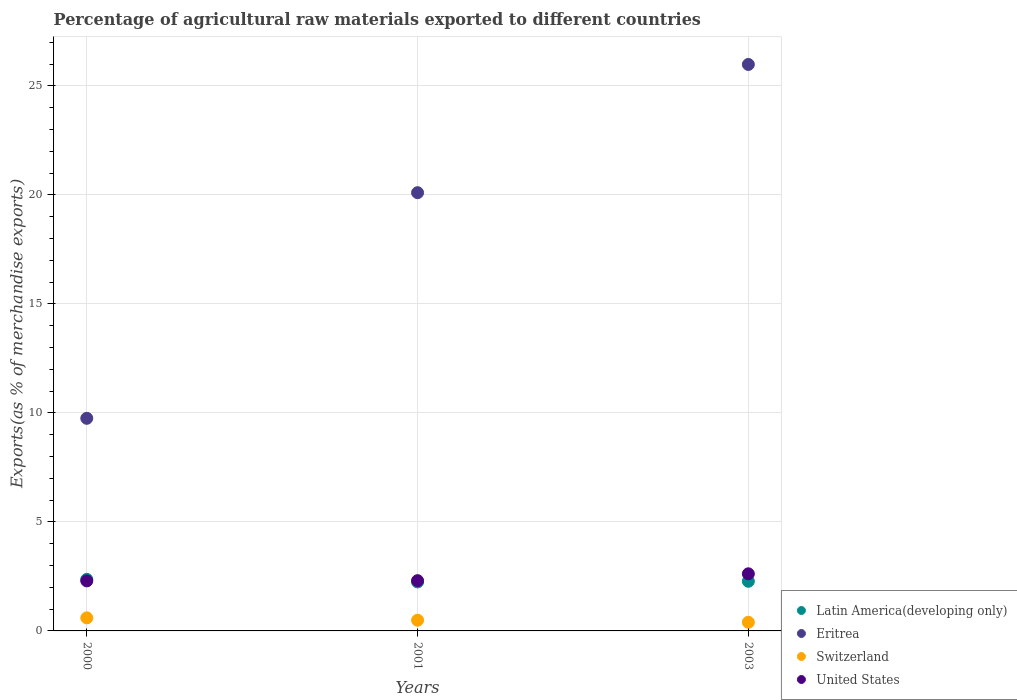What is the percentage of exports to different countries in Switzerland in 2001?
Your response must be concise. 0.49. Across all years, what is the maximum percentage of exports to different countries in Switzerland?
Offer a very short reply. 0.6. Across all years, what is the minimum percentage of exports to different countries in Eritrea?
Provide a succinct answer. 9.75. In which year was the percentage of exports to different countries in United States maximum?
Your response must be concise. 2003. What is the total percentage of exports to different countries in Latin America(developing only) in the graph?
Your response must be concise. 6.89. What is the difference between the percentage of exports to different countries in Switzerland in 2000 and that in 2003?
Provide a succinct answer. 0.2. What is the difference between the percentage of exports to different countries in Eritrea in 2003 and the percentage of exports to different countries in Switzerland in 2000?
Your response must be concise. 25.39. What is the average percentage of exports to different countries in Switzerland per year?
Offer a terse response. 0.5. In the year 2000, what is the difference between the percentage of exports to different countries in Switzerland and percentage of exports to different countries in Latin America(developing only)?
Offer a terse response. -1.77. What is the ratio of the percentage of exports to different countries in Latin America(developing only) in 2000 to that in 2001?
Keep it short and to the point. 1.05. Is the percentage of exports to different countries in Switzerland in 2000 less than that in 2003?
Your answer should be very brief. No. Is the difference between the percentage of exports to different countries in Switzerland in 2000 and 2001 greater than the difference between the percentage of exports to different countries in Latin America(developing only) in 2000 and 2001?
Make the answer very short. No. What is the difference between the highest and the second highest percentage of exports to different countries in Latin America(developing only)?
Your response must be concise. 0.09. What is the difference between the highest and the lowest percentage of exports to different countries in Switzerland?
Keep it short and to the point. 0.2. Is the sum of the percentage of exports to different countries in Eritrea in 2000 and 2001 greater than the maximum percentage of exports to different countries in Switzerland across all years?
Offer a terse response. Yes. Is it the case that in every year, the sum of the percentage of exports to different countries in United States and percentage of exports to different countries in Eritrea  is greater than the sum of percentage of exports to different countries in Switzerland and percentage of exports to different countries in Latin America(developing only)?
Your answer should be very brief. Yes. Is it the case that in every year, the sum of the percentage of exports to different countries in Eritrea and percentage of exports to different countries in United States  is greater than the percentage of exports to different countries in Switzerland?
Give a very brief answer. Yes. Is the percentage of exports to different countries in United States strictly less than the percentage of exports to different countries in Eritrea over the years?
Your answer should be very brief. Yes. How many years are there in the graph?
Your answer should be very brief. 3. What is the difference between two consecutive major ticks on the Y-axis?
Offer a very short reply. 5. Are the values on the major ticks of Y-axis written in scientific E-notation?
Offer a very short reply. No. How many legend labels are there?
Ensure brevity in your answer.  4. What is the title of the graph?
Offer a terse response. Percentage of agricultural raw materials exported to different countries. What is the label or title of the X-axis?
Keep it short and to the point. Years. What is the label or title of the Y-axis?
Your answer should be very brief. Exports(as % of merchandise exports). What is the Exports(as % of merchandise exports) of Latin America(developing only) in 2000?
Offer a very short reply. 2.36. What is the Exports(as % of merchandise exports) in Eritrea in 2000?
Provide a succinct answer. 9.75. What is the Exports(as % of merchandise exports) of Switzerland in 2000?
Ensure brevity in your answer.  0.6. What is the Exports(as % of merchandise exports) in United States in 2000?
Provide a succinct answer. 2.3. What is the Exports(as % of merchandise exports) in Latin America(developing only) in 2001?
Give a very brief answer. 2.25. What is the Exports(as % of merchandise exports) of Eritrea in 2001?
Your response must be concise. 20.1. What is the Exports(as % of merchandise exports) of Switzerland in 2001?
Ensure brevity in your answer.  0.49. What is the Exports(as % of merchandise exports) of United States in 2001?
Ensure brevity in your answer.  2.31. What is the Exports(as % of merchandise exports) in Latin America(developing only) in 2003?
Ensure brevity in your answer.  2.28. What is the Exports(as % of merchandise exports) of Eritrea in 2003?
Give a very brief answer. 25.99. What is the Exports(as % of merchandise exports) of Switzerland in 2003?
Offer a terse response. 0.4. What is the Exports(as % of merchandise exports) in United States in 2003?
Your response must be concise. 2.62. Across all years, what is the maximum Exports(as % of merchandise exports) of Latin America(developing only)?
Your answer should be very brief. 2.36. Across all years, what is the maximum Exports(as % of merchandise exports) of Eritrea?
Your answer should be compact. 25.99. Across all years, what is the maximum Exports(as % of merchandise exports) in Switzerland?
Provide a short and direct response. 0.6. Across all years, what is the maximum Exports(as % of merchandise exports) of United States?
Your response must be concise. 2.62. Across all years, what is the minimum Exports(as % of merchandise exports) of Latin America(developing only)?
Ensure brevity in your answer.  2.25. Across all years, what is the minimum Exports(as % of merchandise exports) in Eritrea?
Keep it short and to the point. 9.75. Across all years, what is the minimum Exports(as % of merchandise exports) in Switzerland?
Keep it short and to the point. 0.4. Across all years, what is the minimum Exports(as % of merchandise exports) of United States?
Give a very brief answer. 2.3. What is the total Exports(as % of merchandise exports) of Latin America(developing only) in the graph?
Offer a very short reply. 6.89. What is the total Exports(as % of merchandise exports) in Eritrea in the graph?
Keep it short and to the point. 55.85. What is the total Exports(as % of merchandise exports) of Switzerland in the graph?
Ensure brevity in your answer.  1.49. What is the total Exports(as % of merchandise exports) in United States in the graph?
Provide a short and direct response. 7.22. What is the difference between the Exports(as % of merchandise exports) in Latin America(developing only) in 2000 and that in 2001?
Your response must be concise. 0.12. What is the difference between the Exports(as % of merchandise exports) of Eritrea in 2000 and that in 2001?
Ensure brevity in your answer.  -10.35. What is the difference between the Exports(as % of merchandise exports) of Switzerland in 2000 and that in 2001?
Give a very brief answer. 0.11. What is the difference between the Exports(as % of merchandise exports) in United States in 2000 and that in 2001?
Ensure brevity in your answer.  -0.01. What is the difference between the Exports(as % of merchandise exports) of Latin America(developing only) in 2000 and that in 2003?
Keep it short and to the point. 0.09. What is the difference between the Exports(as % of merchandise exports) of Eritrea in 2000 and that in 2003?
Offer a very short reply. -16.23. What is the difference between the Exports(as % of merchandise exports) in Switzerland in 2000 and that in 2003?
Provide a short and direct response. 0.2. What is the difference between the Exports(as % of merchandise exports) in United States in 2000 and that in 2003?
Give a very brief answer. -0.32. What is the difference between the Exports(as % of merchandise exports) in Latin America(developing only) in 2001 and that in 2003?
Your answer should be compact. -0.03. What is the difference between the Exports(as % of merchandise exports) in Eritrea in 2001 and that in 2003?
Your answer should be compact. -5.88. What is the difference between the Exports(as % of merchandise exports) of Switzerland in 2001 and that in 2003?
Offer a terse response. 0.09. What is the difference between the Exports(as % of merchandise exports) in United States in 2001 and that in 2003?
Your answer should be very brief. -0.31. What is the difference between the Exports(as % of merchandise exports) in Latin America(developing only) in 2000 and the Exports(as % of merchandise exports) in Eritrea in 2001?
Ensure brevity in your answer.  -17.74. What is the difference between the Exports(as % of merchandise exports) of Latin America(developing only) in 2000 and the Exports(as % of merchandise exports) of Switzerland in 2001?
Give a very brief answer. 1.87. What is the difference between the Exports(as % of merchandise exports) of Latin America(developing only) in 2000 and the Exports(as % of merchandise exports) of United States in 2001?
Offer a very short reply. 0.06. What is the difference between the Exports(as % of merchandise exports) in Eritrea in 2000 and the Exports(as % of merchandise exports) in Switzerland in 2001?
Provide a succinct answer. 9.26. What is the difference between the Exports(as % of merchandise exports) in Eritrea in 2000 and the Exports(as % of merchandise exports) in United States in 2001?
Your answer should be compact. 7.45. What is the difference between the Exports(as % of merchandise exports) of Switzerland in 2000 and the Exports(as % of merchandise exports) of United States in 2001?
Your response must be concise. -1.71. What is the difference between the Exports(as % of merchandise exports) of Latin America(developing only) in 2000 and the Exports(as % of merchandise exports) of Eritrea in 2003?
Keep it short and to the point. -23.62. What is the difference between the Exports(as % of merchandise exports) of Latin America(developing only) in 2000 and the Exports(as % of merchandise exports) of Switzerland in 2003?
Your answer should be compact. 1.97. What is the difference between the Exports(as % of merchandise exports) in Latin America(developing only) in 2000 and the Exports(as % of merchandise exports) in United States in 2003?
Offer a terse response. -0.26. What is the difference between the Exports(as % of merchandise exports) of Eritrea in 2000 and the Exports(as % of merchandise exports) of Switzerland in 2003?
Give a very brief answer. 9.36. What is the difference between the Exports(as % of merchandise exports) in Eritrea in 2000 and the Exports(as % of merchandise exports) in United States in 2003?
Make the answer very short. 7.13. What is the difference between the Exports(as % of merchandise exports) of Switzerland in 2000 and the Exports(as % of merchandise exports) of United States in 2003?
Provide a short and direct response. -2.02. What is the difference between the Exports(as % of merchandise exports) in Latin America(developing only) in 2001 and the Exports(as % of merchandise exports) in Eritrea in 2003?
Provide a succinct answer. -23.74. What is the difference between the Exports(as % of merchandise exports) in Latin America(developing only) in 2001 and the Exports(as % of merchandise exports) in Switzerland in 2003?
Offer a very short reply. 1.85. What is the difference between the Exports(as % of merchandise exports) of Latin America(developing only) in 2001 and the Exports(as % of merchandise exports) of United States in 2003?
Your answer should be very brief. -0.37. What is the difference between the Exports(as % of merchandise exports) in Eritrea in 2001 and the Exports(as % of merchandise exports) in Switzerland in 2003?
Offer a very short reply. 19.71. What is the difference between the Exports(as % of merchandise exports) in Eritrea in 2001 and the Exports(as % of merchandise exports) in United States in 2003?
Offer a terse response. 17.48. What is the difference between the Exports(as % of merchandise exports) of Switzerland in 2001 and the Exports(as % of merchandise exports) of United States in 2003?
Ensure brevity in your answer.  -2.13. What is the average Exports(as % of merchandise exports) in Latin America(developing only) per year?
Offer a very short reply. 2.3. What is the average Exports(as % of merchandise exports) in Eritrea per year?
Offer a terse response. 18.62. What is the average Exports(as % of merchandise exports) of Switzerland per year?
Provide a short and direct response. 0.5. What is the average Exports(as % of merchandise exports) in United States per year?
Provide a short and direct response. 2.41. In the year 2000, what is the difference between the Exports(as % of merchandise exports) of Latin America(developing only) and Exports(as % of merchandise exports) of Eritrea?
Your response must be concise. -7.39. In the year 2000, what is the difference between the Exports(as % of merchandise exports) of Latin America(developing only) and Exports(as % of merchandise exports) of Switzerland?
Your answer should be compact. 1.77. In the year 2000, what is the difference between the Exports(as % of merchandise exports) in Latin America(developing only) and Exports(as % of merchandise exports) in United States?
Make the answer very short. 0.07. In the year 2000, what is the difference between the Exports(as % of merchandise exports) in Eritrea and Exports(as % of merchandise exports) in Switzerland?
Your response must be concise. 9.16. In the year 2000, what is the difference between the Exports(as % of merchandise exports) of Eritrea and Exports(as % of merchandise exports) of United States?
Keep it short and to the point. 7.46. In the year 2000, what is the difference between the Exports(as % of merchandise exports) of Switzerland and Exports(as % of merchandise exports) of United States?
Your answer should be compact. -1.7. In the year 2001, what is the difference between the Exports(as % of merchandise exports) in Latin America(developing only) and Exports(as % of merchandise exports) in Eritrea?
Give a very brief answer. -17.86. In the year 2001, what is the difference between the Exports(as % of merchandise exports) in Latin America(developing only) and Exports(as % of merchandise exports) in Switzerland?
Keep it short and to the point. 1.76. In the year 2001, what is the difference between the Exports(as % of merchandise exports) of Latin America(developing only) and Exports(as % of merchandise exports) of United States?
Provide a short and direct response. -0.06. In the year 2001, what is the difference between the Exports(as % of merchandise exports) in Eritrea and Exports(as % of merchandise exports) in Switzerland?
Offer a very short reply. 19.61. In the year 2001, what is the difference between the Exports(as % of merchandise exports) in Eritrea and Exports(as % of merchandise exports) in United States?
Your response must be concise. 17.8. In the year 2001, what is the difference between the Exports(as % of merchandise exports) of Switzerland and Exports(as % of merchandise exports) of United States?
Offer a terse response. -1.82. In the year 2003, what is the difference between the Exports(as % of merchandise exports) of Latin America(developing only) and Exports(as % of merchandise exports) of Eritrea?
Your answer should be compact. -23.71. In the year 2003, what is the difference between the Exports(as % of merchandise exports) of Latin America(developing only) and Exports(as % of merchandise exports) of Switzerland?
Offer a very short reply. 1.88. In the year 2003, what is the difference between the Exports(as % of merchandise exports) of Latin America(developing only) and Exports(as % of merchandise exports) of United States?
Give a very brief answer. -0.34. In the year 2003, what is the difference between the Exports(as % of merchandise exports) of Eritrea and Exports(as % of merchandise exports) of Switzerland?
Your answer should be very brief. 25.59. In the year 2003, what is the difference between the Exports(as % of merchandise exports) in Eritrea and Exports(as % of merchandise exports) in United States?
Ensure brevity in your answer.  23.37. In the year 2003, what is the difference between the Exports(as % of merchandise exports) of Switzerland and Exports(as % of merchandise exports) of United States?
Provide a short and direct response. -2.22. What is the ratio of the Exports(as % of merchandise exports) of Latin America(developing only) in 2000 to that in 2001?
Give a very brief answer. 1.05. What is the ratio of the Exports(as % of merchandise exports) of Eritrea in 2000 to that in 2001?
Give a very brief answer. 0.49. What is the ratio of the Exports(as % of merchandise exports) in Switzerland in 2000 to that in 2001?
Your answer should be compact. 1.22. What is the ratio of the Exports(as % of merchandise exports) of Latin America(developing only) in 2000 to that in 2003?
Your answer should be very brief. 1.04. What is the ratio of the Exports(as % of merchandise exports) in Eritrea in 2000 to that in 2003?
Give a very brief answer. 0.38. What is the ratio of the Exports(as % of merchandise exports) of Switzerland in 2000 to that in 2003?
Provide a succinct answer. 1.51. What is the ratio of the Exports(as % of merchandise exports) of United States in 2000 to that in 2003?
Keep it short and to the point. 0.88. What is the ratio of the Exports(as % of merchandise exports) in Latin America(developing only) in 2001 to that in 2003?
Offer a terse response. 0.99. What is the ratio of the Exports(as % of merchandise exports) of Eritrea in 2001 to that in 2003?
Keep it short and to the point. 0.77. What is the ratio of the Exports(as % of merchandise exports) of Switzerland in 2001 to that in 2003?
Provide a short and direct response. 1.24. What is the ratio of the Exports(as % of merchandise exports) of United States in 2001 to that in 2003?
Give a very brief answer. 0.88. What is the difference between the highest and the second highest Exports(as % of merchandise exports) in Latin America(developing only)?
Ensure brevity in your answer.  0.09. What is the difference between the highest and the second highest Exports(as % of merchandise exports) of Eritrea?
Your response must be concise. 5.88. What is the difference between the highest and the second highest Exports(as % of merchandise exports) of Switzerland?
Offer a very short reply. 0.11. What is the difference between the highest and the second highest Exports(as % of merchandise exports) of United States?
Your answer should be very brief. 0.31. What is the difference between the highest and the lowest Exports(as % of merchandise exports) of Latin America(developing only)?
Offer a terse response. 0.12. What is the difference between the highest and the lowest Exports(as % of merchandise exports) in Eritrea?
Keep it short and to the point. 16.23. What is the difference between the highest and the lowest Exports(as % of merchandise exports) of Switzerland?
Keep it short and to the point. 0.2. What is the difference between the highest and the lowest Exports(as % of merchandise exports) of United States?
Offer a terse response. 0.32. 